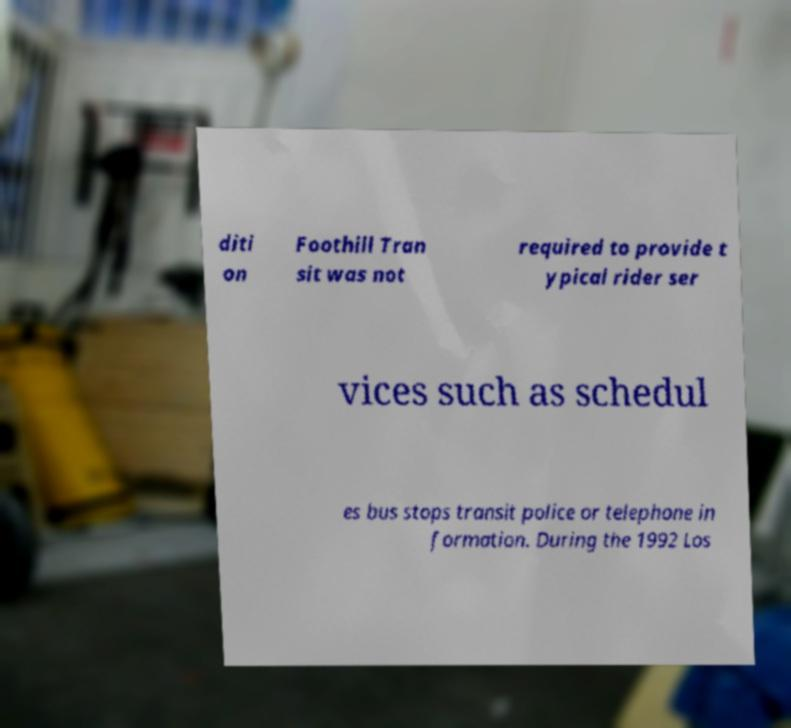Please identify and transcribe the text found in this image. diti on Foothill Tran sit was not required to provide t ypical rider ser vices such as schedul es bus stops transit police or telephone in formation. During the 1992 Los 